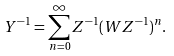Convert formula to latex. <formula><loc_0><loc_0><loc_500><loc_500>Y ^ { - 1 } = \sum _ { n = 0 } ^ { \infty } Z ^ { - 1 } ( W Z ^ { - 1 } ) ^ { n } .</formula> 